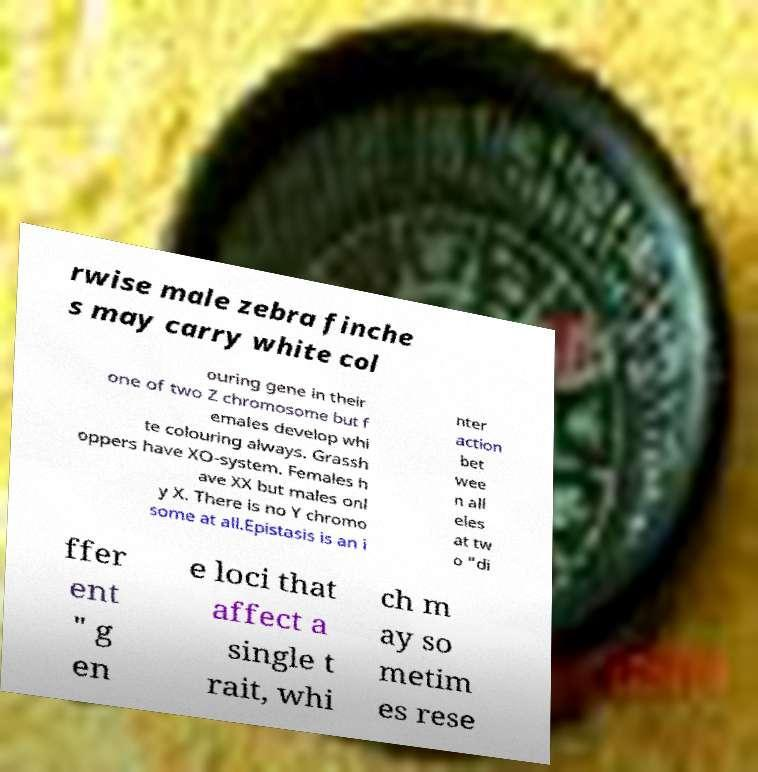Could you assist in decoding the text presented in this image and type it out clearly? rwise male zebra finche s may carry white col ouring gene in their one of two Z chromosome but f emales develop whi te colouring always. Grassh oppers have XO-system. Females h ave XX but males onl y X. There is no Y chromo some at all.Epistasis is an i nter action bet wee n all eles at tw o "di ffer ent " g en e loci that affect a single t rait, whi ch m ay so metim es rese 